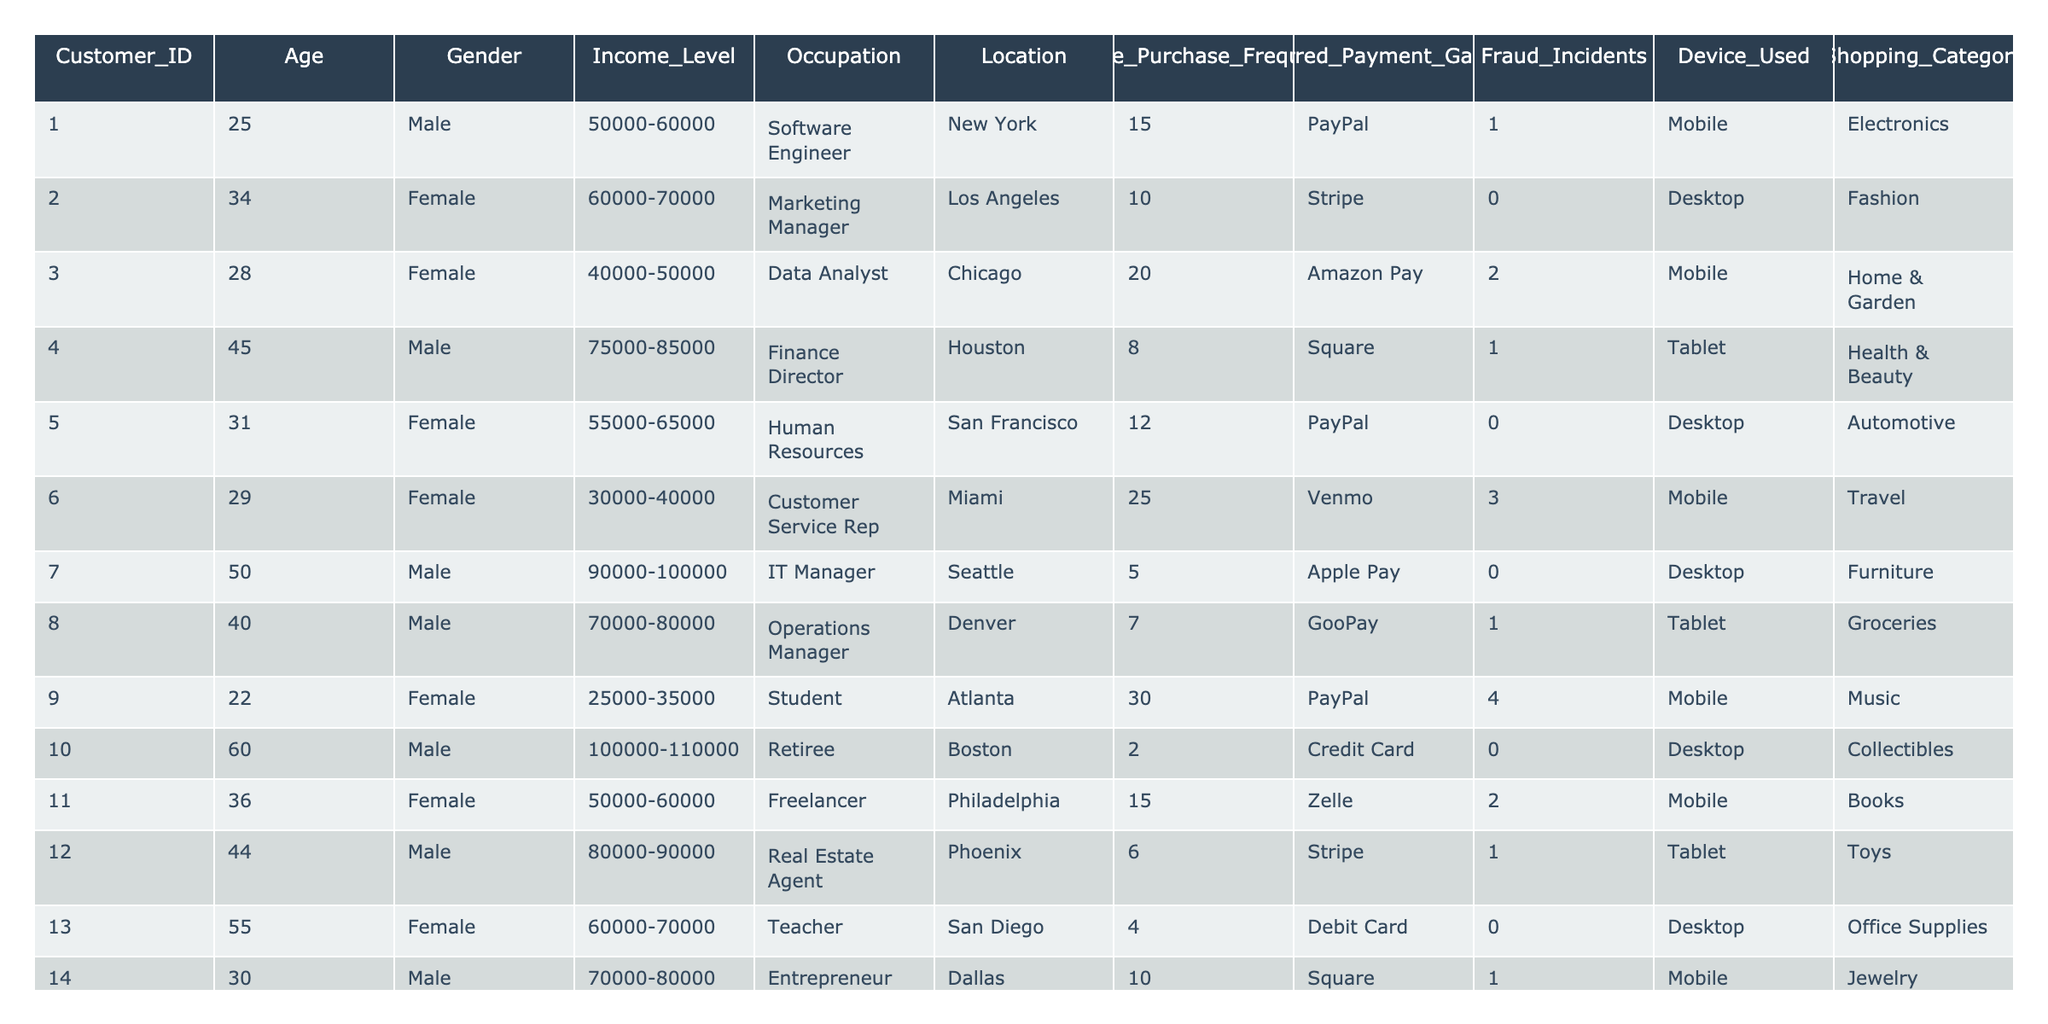What is the age of the customer with ID 7? The customer with ID 7 is listed in the age column as 50.
Answer: 50 How many customers used PayPal as their preferred payment gateway? By counting the rows where the Preferred Payment Gateway is PayPal, we find that there are 4 customers.
Answer: 4 What is the highest online purchase frequency recorded in the table? The highest frequency is 30 from the customer whose ID is 9.
Answer: 30 How many fraud incidents were reported by female customers? Looking through the Fraud Incidents column, the female customers (ID 2, 3, 6, 11, 5, 15) reported a total of 9 fraud incidents.
Answer: 9 What is the average income level of customers using the Stripe payment gateway? The customers using Stripe have the following income levels: 60,000-70,000 (ID 2), 80,000-90,000 (ID 12), so their average is (65000 + 85000)/2 = 75000.
Answer: 75000 Does customer ID 15 have any fraud incidents? Looking in the Fraud Incidents column for customer ID 15, it shows there are 3 incidents reported.
Answer: Yes Which payment gateway has the most users among customers aged 30 and below? Customers aged 30 and below (ID 1, 3, 9, 15) predominantly use PayPal (2 users) while 1 uses Amazon Pay. Thus, PayPal is the most used.
Answer: PayPal What percentage of customers prefer mobile devices for online purchases? There are a total of 15 customers, and among them, 8 (IDs 1, 3, 6, 9, 11, 14, 15) prefer using mobile devices, so the percentage is (8/15)*100 = 53.33%.
Answer: 53.33% How many customers report no fraud incidents and what is their average age? The customers with no fraud incidents are IDs 2, 5, 7, 10, 13, and they have ages of 34, 31, 50, 60, and 55 respectively, which gives an average age of (34 + 31 + 50 + 60 + 55)/5 = 46.
Answer: 46 Is there any customer over 60 years old who experienced fraud incidents? Customer ID 10 is over 60 but has 0 fraud incidents, so the answer is no.
Answer: No 